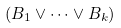Convert formula to latex. <formula><loc_0><loc_0><loc_500><loc_500>( B _ { 1 } \lor \cdots \lor B _ { k } )</formula> 